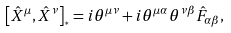Convert formula to latex. <formula><loc_0><loc_0><loc_500><loc_500>\left [ \hat { X } ^ { \mu } , \hat { X } ^ { \nu } \right ] _ { ^ { * } } = i \theta ^ { \mu \nu } + i \theta ^ { \mu \alpha } \theta ^ { \nu \beta } \hat { F } _ { \alpha \beta } ,</formula> 